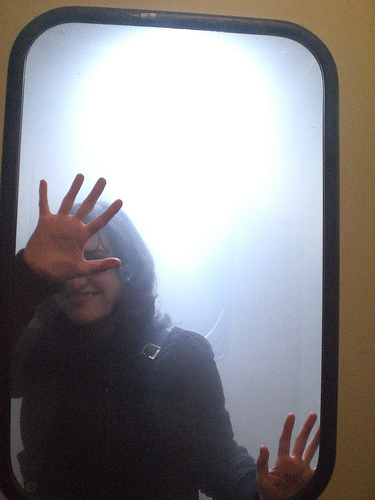<image>
Can you confirm if the woman is in front of the glass? No. The woman is not in front of the glass. The spatial positioning shows a different relationship between these objects. 